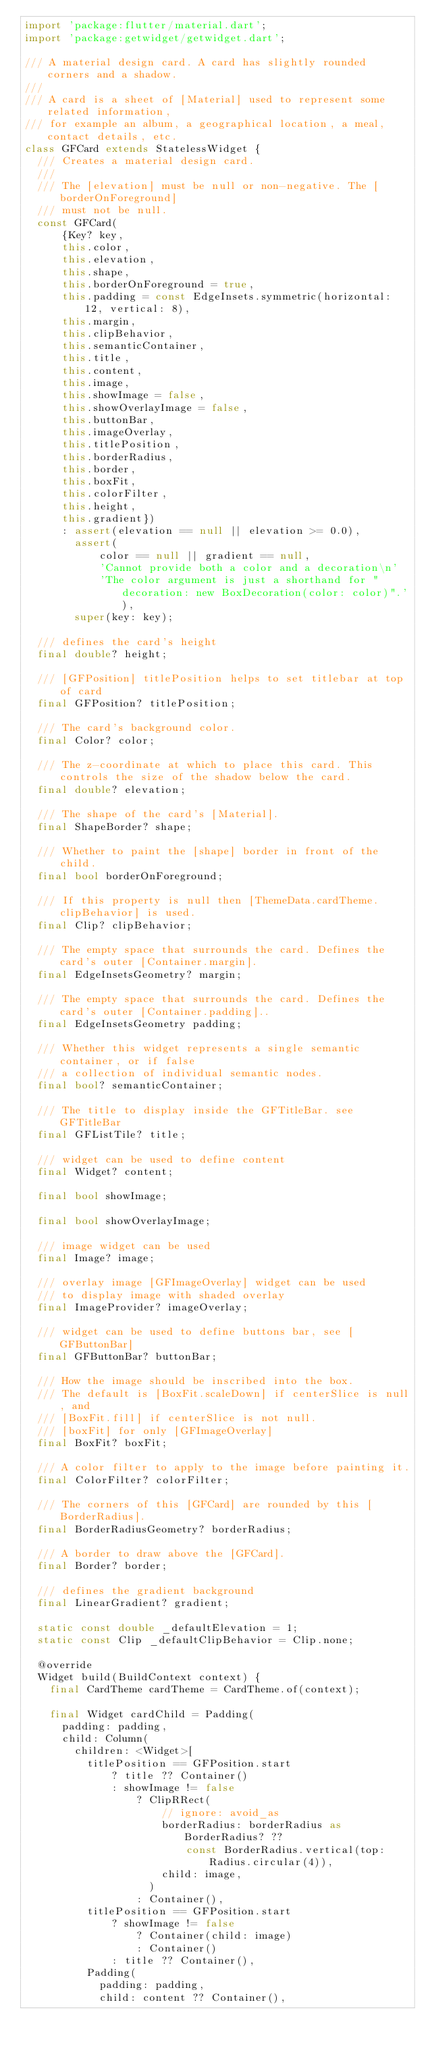Convert code to text. <code><loc_0><loc_0><loc_500><loc_500><_Dart_>import 'package:flutter/material.dart';
import 'package:getwidget/getwidget.dart';

/// A material design card. A card has slightly rounded corners and a shadow.
///
/// A card is a sheet of [Material] used to represent some related information,
/// for example an album, a geographical location, a meal, contact details, etc.
class GFCard extends StatelessWidget {
  /// Creates a material design card.
  ///
  /// The [elevation] must be null or non-negative. The [borderOnForeground]
  /// must not be null.
  const GFCard(
      {Key? key,
      this.color,
      this.elevation,
      this.shape,
      this.borderOnForeground = true,
      this.padding = const EdgeInsets.symmetric(horizontal: 12, vertical: 8),
      this.margin,
      this.clipBehavior,
      this.semanticContainer,
      this.title,
      this.content,
      this.image,
      this.showImage = false,
      this.showOverlayImage = false,
      this.buttonBar,
      this.imageOverlay,
      this.titlePosition,
      this.borderRadius,
      this.border,
      this.boxFit,
      this.colorFilter,
      this.height,
      this.gradient})
      : assert(elevation == null || elevation >= 0.0),
        assert(
            color == null || gradient == null,
            'Cannot provide both a color and a decoration\n'
            'The color argument is just a shorthand for "decoration: new BoxDecoration(color: color)".'),
        super(key: key);

  /// defines the card's height
  final double? height;

  /// [GFPosition] titlePosition helps to set titlebar at top of card
  final GFPosition? titlePosition;

  /// The card's background color.
  final Color? color;

  /// The z-coordinate at which to place this card. This controls the size of the shadow below the card.
  final double? elevation;

  /// The shape of the card's [Material].
  final ShapeBorder? shape;

  /// Whether to paint the [shape] border in front of the child.
  final bool borderOnForeground;

  /// If this property is null then [ThemeData.cardTheme.clipBehavior] is used.
  final Clip? clipBehavior;

  /// The empty space that surrounds the card. Defines the card's outer [Container.margin].
  final EdgeInsetsGeometry? margin;

  /// The empty space that surrounds the card. Defines the card's outer [Container.padding]..
  final EdgeInsetsGeometry padding;

  /// Whether this widget represents a single semantic container, or if false
  /// a collection of individual semantic nodes.
  final bool? semanticContainer;

  /// The title to display inside the GFTitleBar. see GFTitleBar
  final GFListTile? title;

  /// widget can be used to define content
  final Widget? content;

  final bool showImage;

  final bool showOverlayImage;

  /// image widget can be used
  final Image? image;

  /// overlay image [GFImageOverlay] widget can be used
  /// to display image with shaded overlay
  final ImageProvider? imageOverlay;

  /// widget can be used to define buttons bar, see [GFButtonBar]
  final GFButtonBar? buttonBar;

  /// How the image should be inscribed into the box.
  /// The default is [BoxFit.scaleDown] if centerSlice is null, and
  /// [BoxFit.fill] if centerSlice is not null.
  /// [boxFit] for only [GFImageOverlay]
  final BoxFit? boxFit;

  /// A color filter to apply to the image before painting it.
  final ColorFilter? colorFilter;

  /// The corners of this [GFCard] are rounded by this [BorderRadius].
  final BorderRadiusGeometry? borderRadius;

  /// A border to draw above the [GFCard].
  final Border? border;

  /// defines the gradient background
  final LinearGradient? gradient;

  static const double _defaultElevation = 1;
  static const Clip _defaultClipBehavior = Clip.none;

  @override
  Widget build(BuildContext context) {
    final CardTheme cardTheme = CardTheme.of(context);

    final Widget cardChild = Padding(
      padding: padding,
      child: Column(
        children: <Widget>[
          titlePosition == GFPosition.start
              ? title ?? Container()
              : showImage != false
                  ? ClipRRect(
                      // ignore: avoid_as
                      borderRadius: borderRadius as BorderRadius? ??
                          const BorderRadius.vertical(top: Radius.circular(4)),
                      child: image,
                    )
                  : Container(),
          titlePosition == GFPosition.start
              ? showImage != false
                  ? Container(child: image)
                  : Container()
              : title ?? Container(),
          Padding(
            padding: padding,
            child: content ?? Container(),</code> 